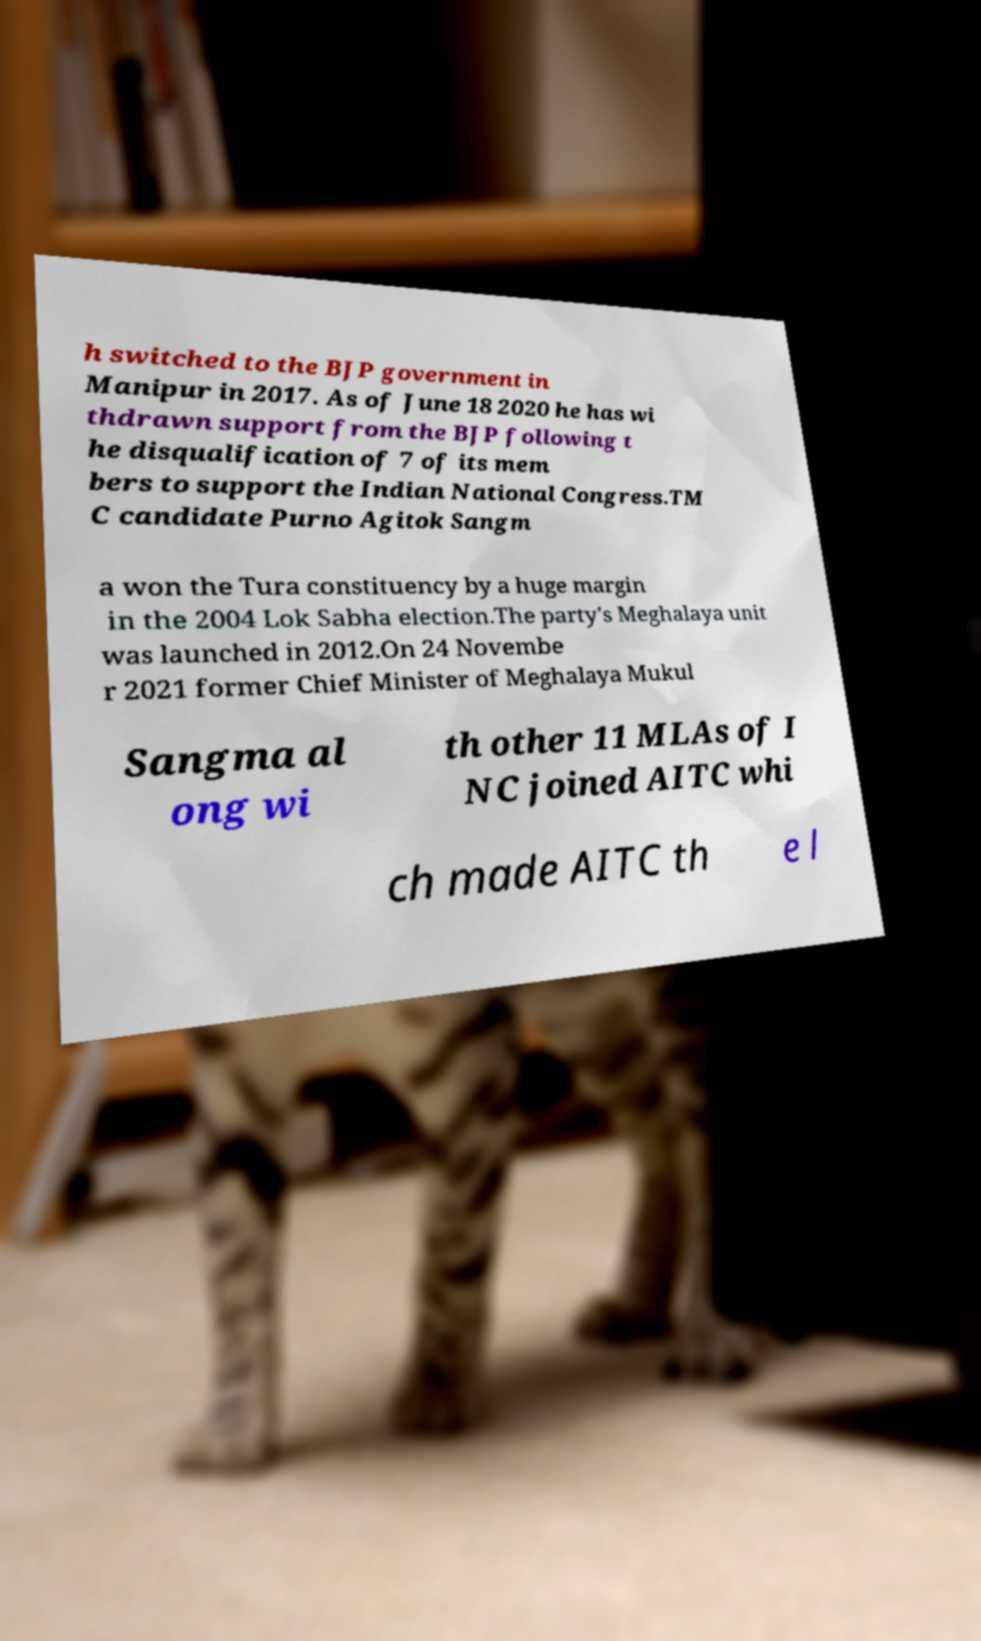Could you extract and type out the text from this image? h switched to the BJP government in Manipur in 2017. As of June 18 2020 he has wi thdrawn support from the BJP following t he disqualification of 7 of its mem bers to support the Indian National Congress.TM C candidate Purno Agitok Sangm a won the Tura constituency by a huge margin in the 2004 Lok Sabha election.The party's Meghalaya unit was launched in 2012.On 24 Novembe r 2021 former Chief Minister of Meghalaya Mukul Sangma al ong wi th other 11 MLAs of I NC joined AITC whi ch made AITC th e l 